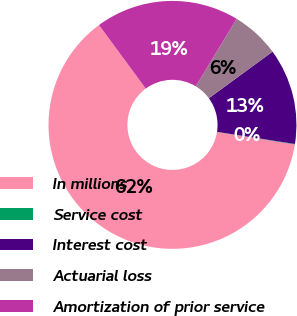<chart> <loc_0><loc_0><loc_500><loc_500><pie_chart><fcel>In millions<fcel>Service cost<fcel>Interest cost<fcel>Actuarial loss<fcel>Amortization of prior service<nl><fcel>62.37%<fcel>0.06%<fcel>12.52%<fcel>6.29%<fcel>18.75%<nl></chart> 